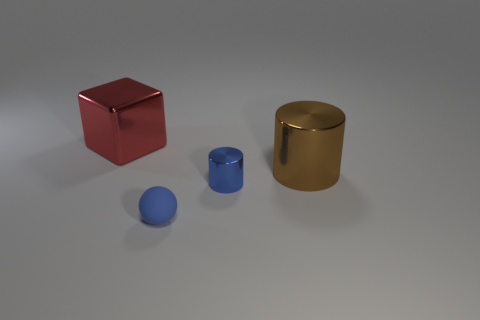Add 1 shiny blocks. How many objects exist? 5 Subtract 1 spheres. How many spheres are left? 0 Add 3 large brown cylinders. How many large brown cylinders are left? 4 Add 2 yellow matte cylinders. How many yellow matte cylinders exist? 2 Subtract 1 blue cylinders. How many objects are left? 3 Subtract all yellow cylinders. Subtract all green spheres. How many cylinders are left? 2 Subtract all cyan balls. How many cyan cylinders are left? 0 Subtract all cyan cubes. Subtract all large shiny cylinders. How many objects are left? 3 